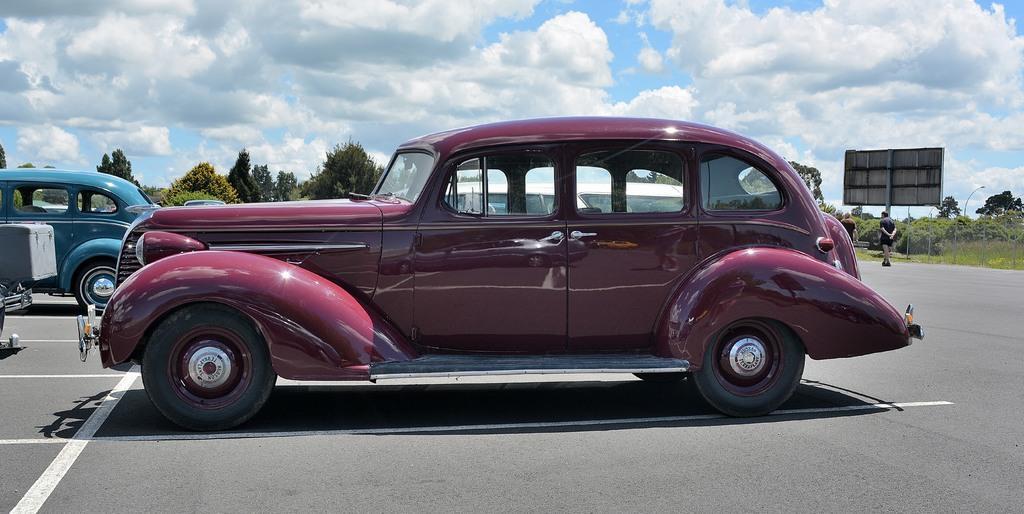How would you summarize this image in a sentence or two? We can see cars on the road. There are people walking. In the background we can see hoarding and light on poles, grass, plants, trees and sky with clouds. 